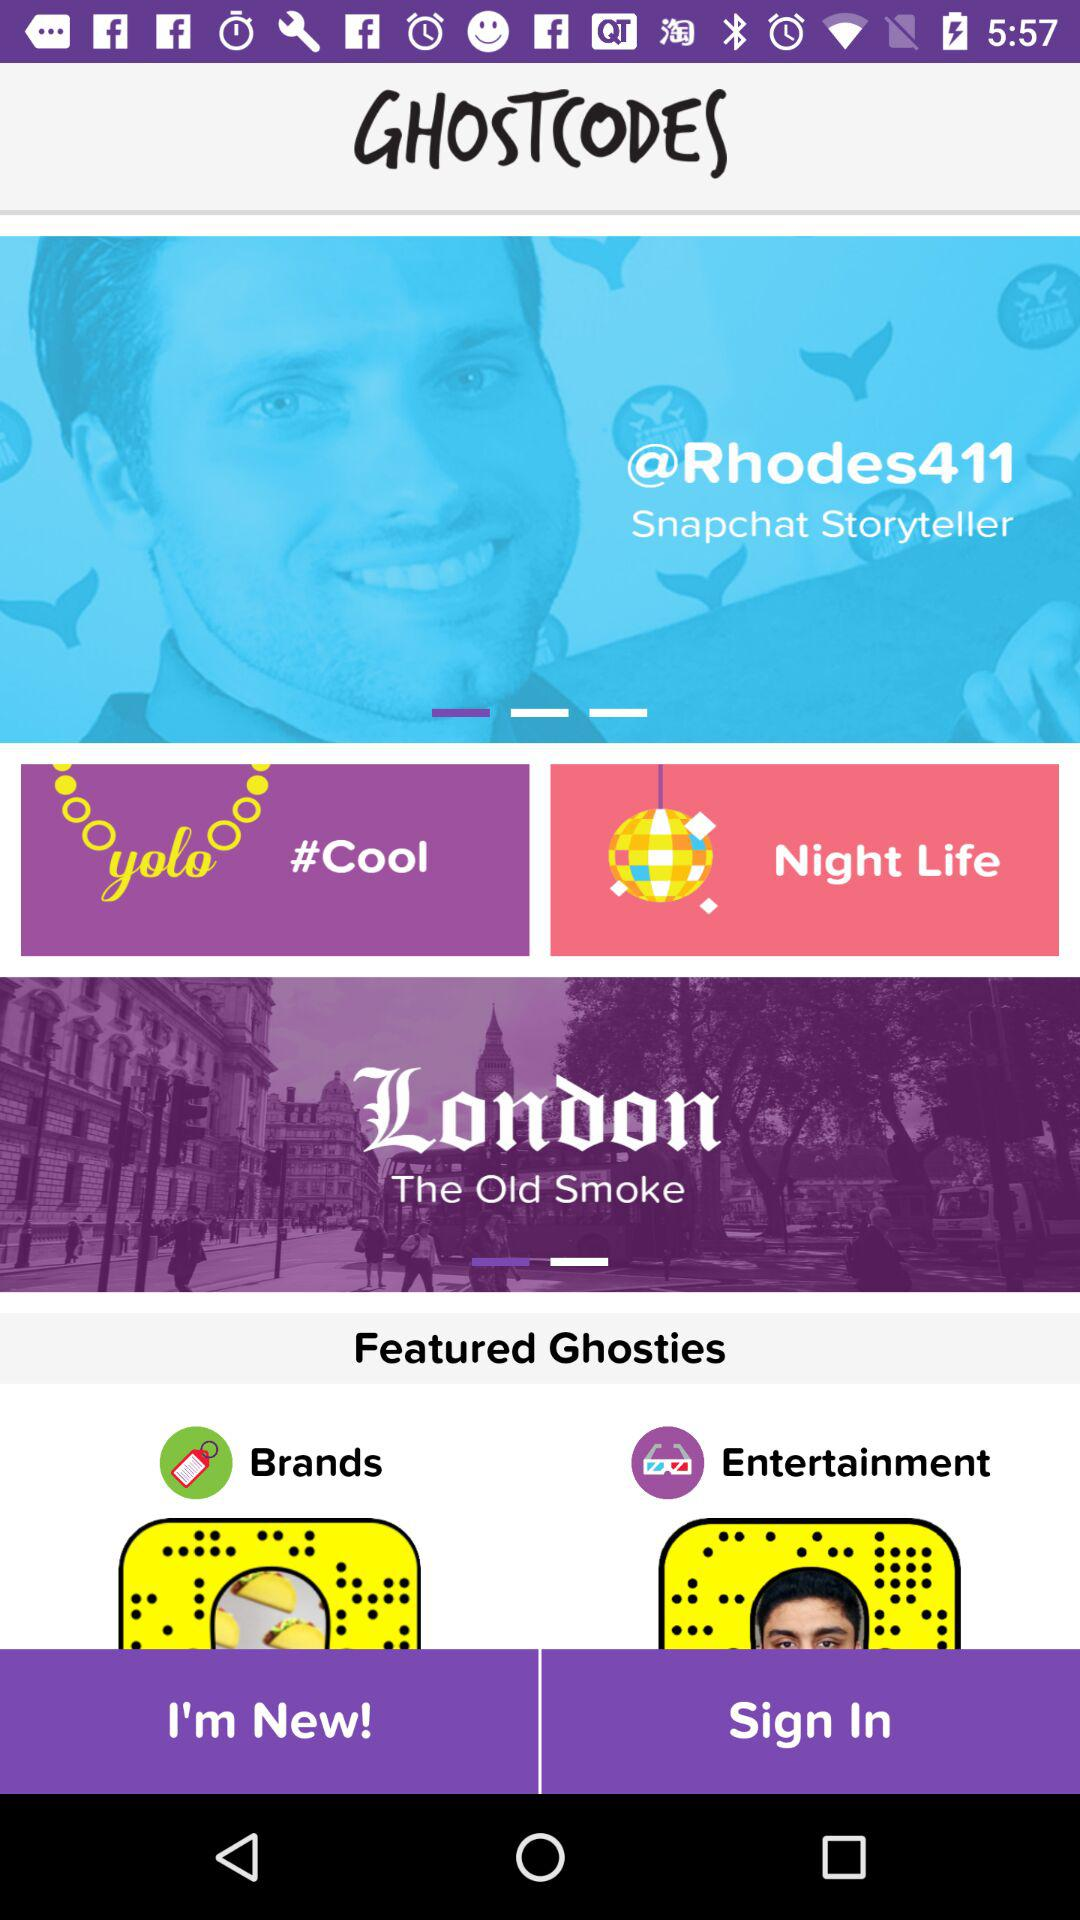What is the username? The username is "Rhodes411". 